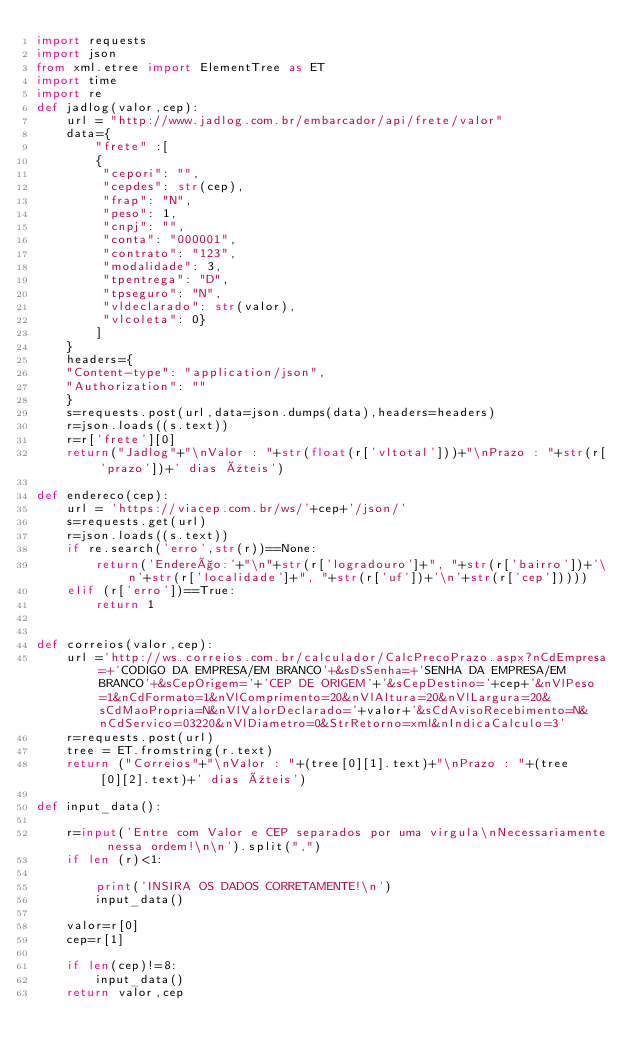Convert code to text. <code><loc_0><loc_0><loc_500><loc_500><_Python_>import requests
import json
from xml.etree import ElementTree as ET
import time
import re
def jadlog(valor,cep):
    url = "http://www.jadlog.com.br/embarcador/api/frete/valor"
    data={
        "frete" :[
        {
         "cepori": "",
         "cepdes": str(cep),
         "frap": "N",
         "peso": 1,
         "cnpj": "",
         "conta": "000001",
         "contrato": "123",
         "modalidade": 3,
         "tpentrega": "D",
         "tpseguro": "N",
         "vldeclarado": str(valor),
         "vlcoleta": 0}
        ]
    }
    headers={
    "Content-type": "application/json",
    "Authorization": ""
    }
    s=requests.post(url,data=json.dumps(data),headers=headers)
    r=json.loads((s.text))
    r=r['frete'][0]
    return("Jadlog"+"\nValor : "+str(float(r['vltotal']))+"\nPrazo : "+str(r['prazo'])+' dias úteis')

def endereco(cep):
    url = 'https://viacep.com.br/ws/'+cep+'/json/'
    s=requests.get(url)
    r=json.loads((s.text))
    if re.search('erro',str(r))==None:
        return('Endereço:'+"\n"+str(r['logradouro']+", "+str(r['bairro'])+'\n'+str(r['localidade']+", "+str(r['uf'])+'\n'+str(r['cep']))))
    elif (r['erro'])==True:
        return 1

    
def correios(valor,cep):
    url ='http://ws.correios.com.br/calculador/CalcPrecoPrazo.aspx?nCdEmpresa=+'CODIGO DA EMPRESA/EM BRANCO'+&sDsSenha=+'SENHA DA EMPRESA/EM BRANCO'+&sCepOrigem='+'CEP DE ORIGEM'+'&sCepDestino='+cep+'&nVlPeso=1&nCdFormato=1&nVlComprimento=20&nVlAltura=20&nVlLargura=20&sCdMaoPropria=N&nVlValorDeclarado='+valor+'&sCdAvisoRecebimento=N&nCdServico=03220&nVlDiametro=0&StrRetorno=xml&nIndicaCalculo=3'
    r=requests.post(url)
    tree = ET.fromstring(r.text)
    return ("Correios"+"\nValor : "+(tree[0][1].text)+"\nPrazo : "+(tree[0][2].text)+' dias úteis')

def input_data():

    r=input('Entre com Valor e CEP separados por uma virgula\nNecessariamente nessa ordem!\n\n').split(",")
    if len (r)<1:
        
        print('INSIRA OS DADOS CORRETAMENTE!\n')
        input_data()

    valor=r[0]
    cep=r[1]
    
    if len(cep)!=8:
        input_data()
    return valor,cep
</code> 